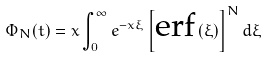<formula> <loc_0><loc_0><loc_500><loc_500>\Phi _ { N } ( t ) = x \int _ { 0 } ^ { \infty } e ^ { - x \xi } \left [ \text {erf} \left ( \xi \right ) \right ] ^ { N } d \xi</formula> 